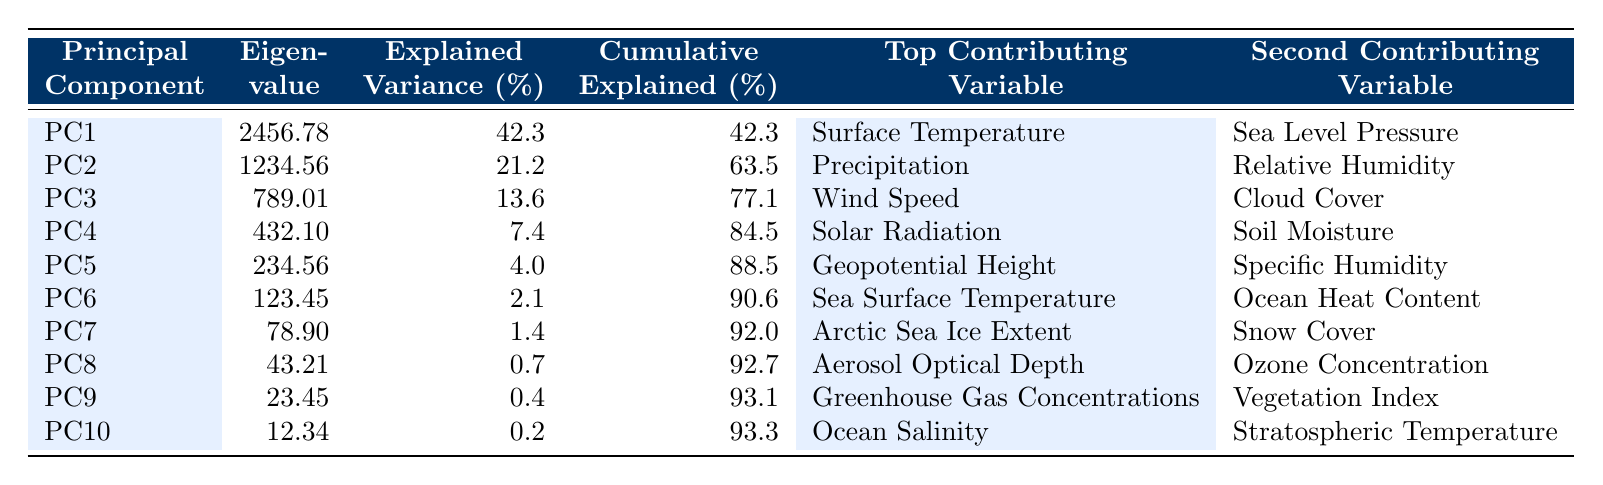What is the eigenvalue of PC1? The table lists the eigenvalue for PC1 as 2456.78, which is directly provided in the corresponding row under the "Eigenvalue" column.
Answer: 2456.78 Which principal component explains the greatest variance? By looking at the "Explained Variance (%)" column, PC1 has the highest value at 42.3%, indicating it explains the greatest variance among the components.
Answer: PC1 What is the cumulative explained variance after PC3? Checking the "Cumulative Explained Variance (%)" column, after PC3, the cumulative explained variance is 77.1%, which is noted in its corresponding row.
Answer: 77.1% How much variance is explained by the first two principal components combined? The explained variances for PC1 and PC2 are 42.3% and 21.2% respectively. Adding these gives 42.3 + 21.2 = 63.5%.
Answer: 63.5% Which variable contributes the most to PC2? Referring to the "Top Contributing Variable" column in the row for PC2, it states "Precipitation" as the top contributing variable.
Answer: Precipitation Is there a principal component that explains less than 1% of the variance? By scanning the "Explained Variance (%)" column, the values for PC8 (0.7%) and PC9 (0.4%) both indicate that there are components that explain less than 1% of the variance.
Answer: Yes What is the cumulative explained variance for PC6? The cumulative explained variance for PC6 is found in the "Cumulative Explained Variance (%)" column for that component, which shows 90.6%.
Answer: 90.6% Which two variables are the second largest contributors for PC5? Looking at the row for PC5, the "Second Contributing Variable" shows "Specific Humidity." The "Top Contributing Variable" lists "Geopotential Height."
Answer: Specific Humidity What is the difference in eigenvalue between PC1 and PC4? The eigenvalue of PC1 is 2456.78 and that of PC4 is 432.10. Calculating the difference gives 2456.78 - 432.10 = 2024.68.
Answer: 2024.68 How many principal components explain more than 10% of the variance? Checking the "Explained Variance (%)" column, PC1 (42.3%), PC2 (21.2%), and PC3 (13.6%) are the only components that explain more than 10%. This totals three components.
Answer: 3 